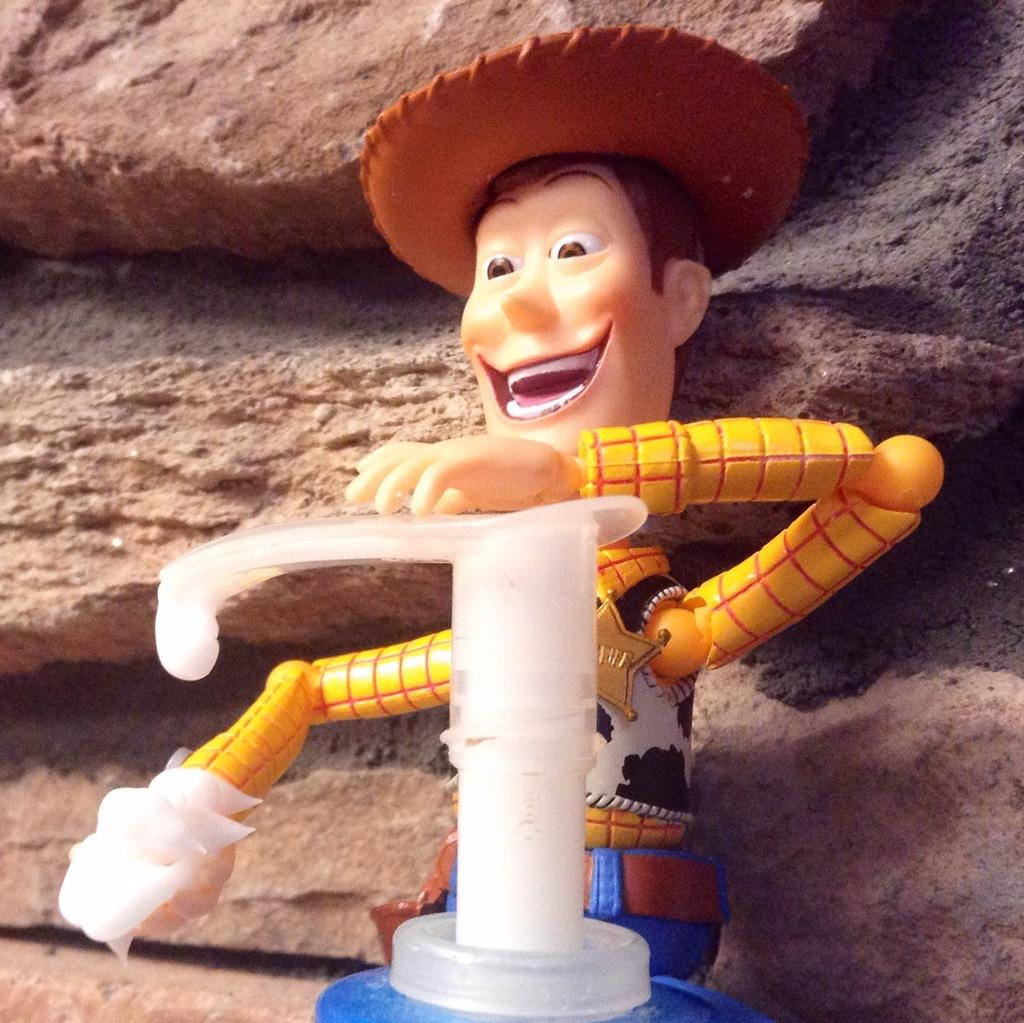What is the main subject in the center of the image? There is a toy in the center of the image. What can be seen in the background of the image? There are rocks in the background of the image. How does the airplane fly in the image? There is no airplane present in the image, so it cannot fly. 